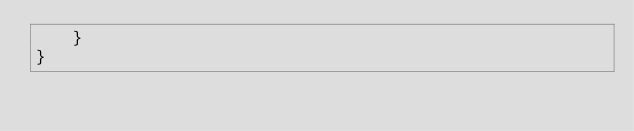<code> <loc_0><loc_0><loc_500><loc_500><_Java_>    }
}
</code> 